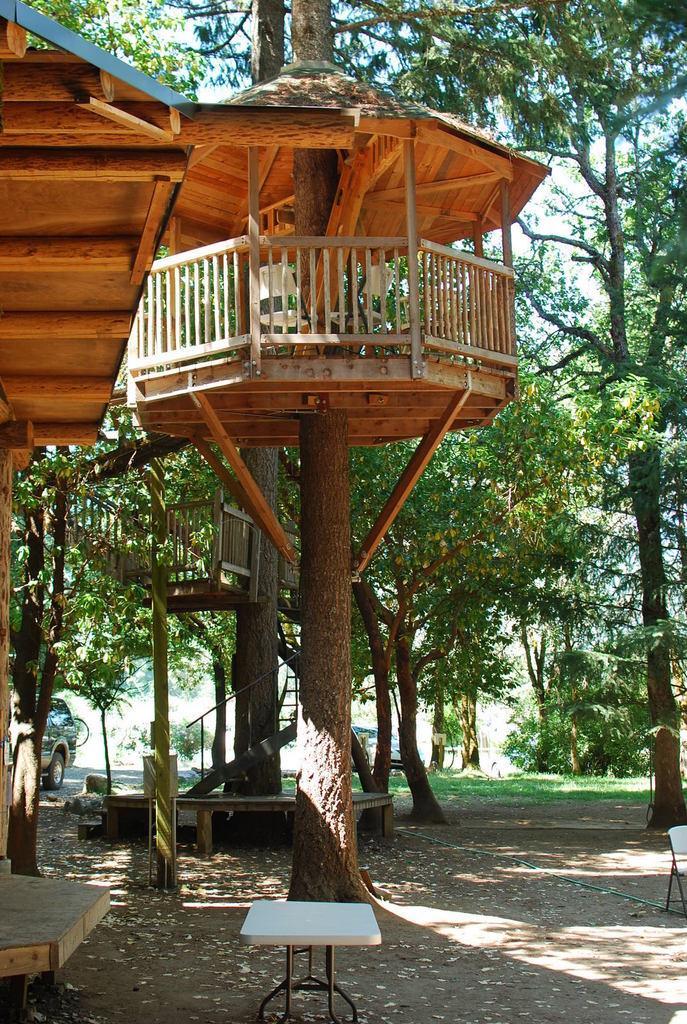Describe this image in one or two sentences. In this picture there is a small hut in the middle of the image, on which there are chairs and there is a table at the bottom side of the image and there are cars and trees in the background area of the image, there is a roof on the left side of the image and there is a chair on the right side of the image. 